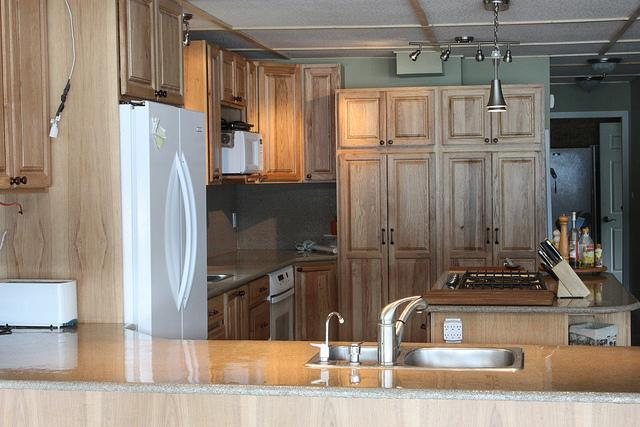Why are there wires sticking out of the wall? electrical 